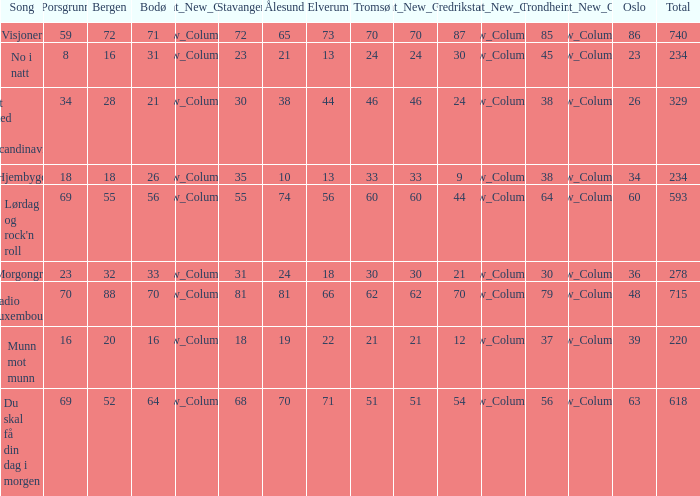With a total score of 740, what is the meaning of tromso? 70.0. 